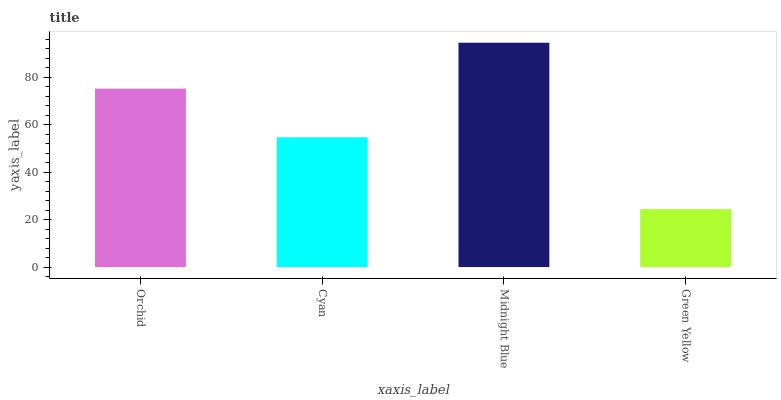Is Green Yellow the minimum?
Answer yes or no. Yes. Is Midnight Blue the maximum?
Answer yes or no. Yes. Is Cyan the minimum?
Answer yes or no. No. Is Cyan the maximum?
Answer yes or no. No. Is Orchid greater than Cyan?
Answer yes or no. Yes. Is Cyan less than Orchid?
Answer yes or no. Yes. Is Cyan greater than Orchid?
Answer yes or no. No. Is Orchid less than Cyan?
Answer yes or no. No. Is Orchid the high median?
Answer yes or no. Yes. Is Cyan the low median?
Answer yes or no. Yes. Is Midnight Blue the high median?
Answer yes or no. No. Is Midnight Blue the low median?
Answer yes or no. No. 